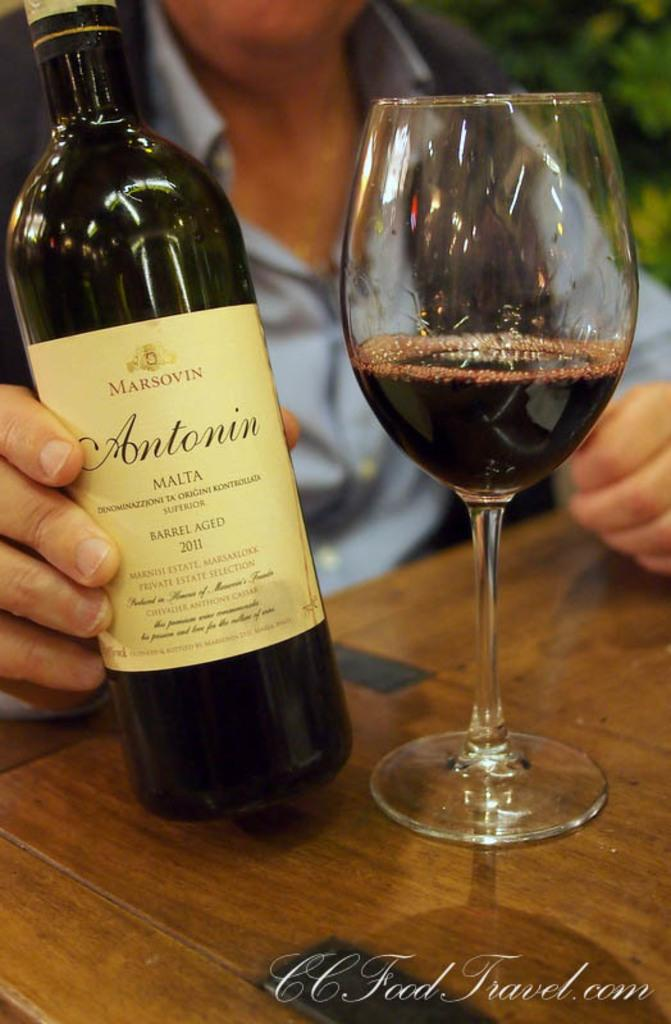<image>
Give a short and clear explanation of the subsequent image. A bottle of Antonin wine is held next to a wine glass on a table. 